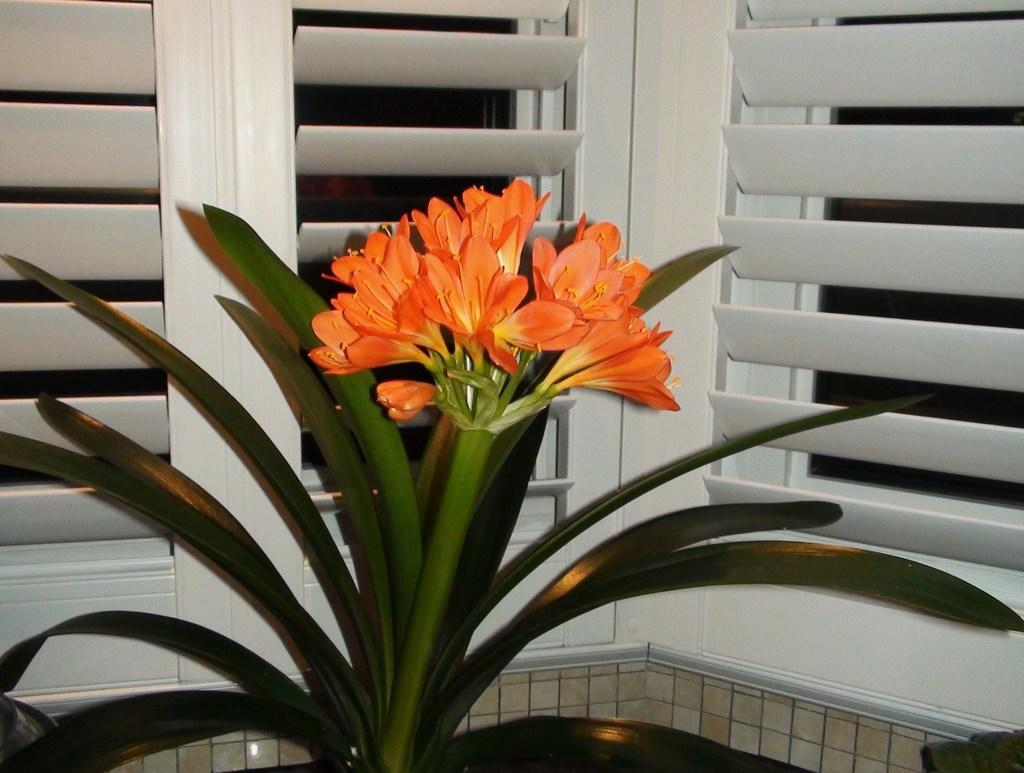What type of plant can be seen in the image? There is a green plant in the image. What other floral elements are present in the image? There are flowers in the image. What color are the windows visible in the image? The windows in the image are white-colored. What type of chain is being used for arithmetic calculations in the image? There is no chain or arithmetic calculations present in the image. What color is the vest worn by the plant in the image? There is no vest worn by the plant in the image, as plants do not wear clothing. 